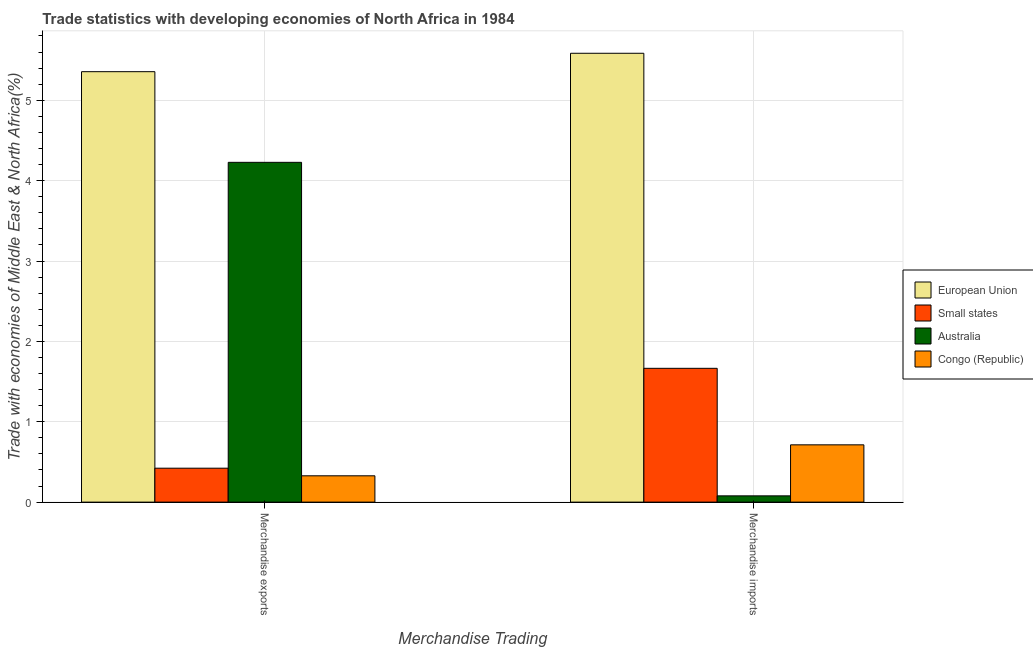Are the number of bars on each tick of the X-axis equal?
Give a very brief answer. Yes. What is the label of the 2nd group of bars from the left?
Provide a succinct answer. Merchandise imports. What is the merchandise imports in Australia?
Give a very brief answer. 0.08. Across all countries, what is the maximum merchandise exports?
Provide a short and direct response. 5.36. Across all countries, what is the minimum merchandise exports?
Provide a succinct answer. 0.33. In which country was the merchandise imports maximum?
Give a very brief answer. European Union. In which country was the merchandise exports minimum?
Make the answer very short. Congo (Republic). What is the total merchandise imports in the graph?
Offer a terse response. 8.04. What is the difference between the merchandise exports in Australia and that in European Union?
Your answer should be very brief. -1.13. What is the difference between the merchandise imports in European Union and the merchandise exports in Congo (Republic)?
Offer a very short reply. 5.26. What is the average merchandise imports per country?
Your answer should be compact. 2.01. What is the difference between the merchandise exports and merchandise imports in Australia?
Offer a very short reply. 4.15. What is the ratio of the merchandise imports in Australia to that in Congo (Republic)?
Your answer should be compact. 0.11. In how many countries, is the merchandise imports greater than the average merchandise imports taken over all countries?
Offer a terse response. 1. What does the 2nd bar from the left in Merchandise exports represents?
Give a very brief answer. Small states. What does the 2nd bar from the right in Merchandise imports represents?
Provide a succinct answer. Australia. How many legend labels are there?
Your response must be concise. 4. How are the legend labels stacked?
Your answer should be compact. Vertical. What is the title of the graph?
Your answer should be very brief. Trade statistics with developing economies of North Africa in 1984. Does "Low income" appear as one of the legend labels in the graph?
Make the answer very short. No. What is the label or title of the X-axis?
Offer a very short reply. Merchandise Trading. What is the label or title of the Y-axis?
Provide a succinct answer. Trade with economies of Middle East & North Africa(%). What is the Trade with economies of Middle East & North Africa(%) in European Union in Merchandise exports?
Your answer should be compact. 5.36. What is the Trade with economies of Middle East & North Africa(%) of Small states in Merchandise exports?
Offer a very short reply. 0.42. What is the Trade with economies of Middle East & North Africa(%) of Australia in Merchandise exports?
Ensure brevity in your answer.  4.23. What is the Trade with economies of Middle East & North Africa(%) in Congo (Republic) in Merchandise exports?
Make the answer very short. 0.33. What is the Trade with economies of Middle East & North Africa(%) in European Union in Merchandise imports?
Offer a terse response. 5.58. What is the Trade with economies of Middle East & North Africa(%) of Small states in Merchandise imports?
Your answer should be very brief. 1.66. What is the Trade with economies of Middle East & North Africa(%) of Australia in Merchandise imports?
Ensure brevity in your answer.  0.08. What is the Trade with economies of Middle East & North Africa(%) in Congo (Republic) in Merchandise imports?
Offer a very short reply. 0.71. Across all Merchandise Trading, what is the maximum Trade with economies of Middle East & North Africa(%) of European Union?
Your answer should be very brief. 5.58. Across all Merchandise Trading, what is the maximum Trade with economies of Middle East & North Africa(%) in Small states?
Your response must be concise. 1.66. Across all Merchandise Trading, what is the maximum Trade with economies of Middle East & North Africa(%) of Australia?
Your answer should be compact. 4.23. Across all Merchandise Trading, what is the maximum Trade with economies of Middle East & North Africa(%) of Congo (Republic)?
Provide a short and direct response. 0.71. Across all Merchandise Trading, what is the minimum Trade with economies of Middle East & North Africa(%) in European Union?
Keep it short and to the point. 5.36. Across all Merchandise Trading, what is the minimum Trade with economies of Middle East & North Africa(%) of Small states?
Provide a short and direct response. 0.42. Across all Merchandise Trading, what is the minimum Trade with economies of Middle East & North Africa(%) in Australia?
Offer a very short reply. 0.08. Across all Merchandise Trading, what is the minimum Trade with economies of Middle East & North Africa(%) in Congo (Republic)?
Your answer should be very brief. 0.33. What is the total Trade with economies of Middle East & North Africa(%) of European Union in the graph?
Offer a very short reply. 10.94. What is the total Trade with economies of Middle East & North Africa(%) of Small states in the graph?
Offer a terse response. 2.09. What is the total Trade with economies of Middle East & North Africa(%) in Australia in the graph?
Provide a short and direct response. 4.31. What is the total Trade with economies of Middle East & North Africa(%) in Congo (Republic) in the graph?
Offer a very short reply. 1.04. What is the difference between the Trade with economies of Middle East & North Africa(%) in European Union in Merchandise exports and that in Merchandise imports?
Offer a very short reply. -0.23. What is the difference between the Trade with economies of Middle East & North Africa(%) in Small states in Merchandise exports and that in Merchandise imports?
Provide a short and direct response. -1.24. What is the difference between the Trade with economies of Middle East & North Africa(%) in Australia in Merchandise exports and that in Merchandise imports?
Keep it short and to the point. 4.15. What is the difference between the Trade with economies of Middle East & North Africa(%) in Congo (Republic) in Merchandise exports and that in Merchandise imports?
Provide a short and direct response. -0.39. What is the difference between the Trade with economies of Middle East & North Africa(%) of European Union in Merchandise exports and the Trade with economies of Middle East & North Africa(%) of Small states in Merchandise imports?
Provide a succinct answer. 3.69. What is the difference between the Trade with economies of Middle East & North Africa(%) in European Union in Merchandise exports and the Trade with economies of Middle East & North Africa(%) in Australia in Merchandise imports?
Your answer should be compact. 5.28. What is the difference between the Trade with economies of Middle East & North Africa(%) of European Union in Merchandise exports and the Trade with economies of Middle East & North Africa(%) of Congo (Republic) in Merchandise imports?
Make the answer very short. 4.64. What is the difference between the Trade with economies of Middle East & North Africa(%) of Small states in Merchandise exports and the Trade with economies of Middle East & North Africa(%) of Australia in Merchandise imports?
Provide a short and direct response. 0.34. What is the difference between the Trade with economies of Middle East & North Africa(%) of Small states in Merchandise exports and the Trade with economies of Middle East & North Africa(%) of Congo (Republic) in Merchandise imports?
Offer a very short reply. -0.29. What is the difference between the Trade with economies of Middle East & North Africa(%) of Australia in Merchandise exports and the Trade with economies of Middle East & North Africa(%) of Congo (Republic) in Merchandise imports?
Give a very brief answer. 3.52. What is the average Trade with economies of Middle East & North Africa(%) in European Union per Merchandise Trading?
Your answer should be compact. 5.47. What is the average Trade with economies of Middle East & North Africa(%) in Small states per Merchandise Trading?
Give a very brief answer. 1.04. What is the average Trade with economies of Middle East & North Africa(%) of Australia per Merchandise Trading?
Ensure brevity in your answer.  2.15. What is the average Trade with economies of Middle East & North Africa(%) in Congo (Republic) per Merchandise Trading?
Offer a terse response. 0.52. What is the difference between the Trade with economies of Middle East & North Africa(%) of European Union and Trade with economies of Middle East & North Africa(%) of Small states in Merchandise exports?
Your answer should be compact. 4.93. What is the difference between the Trade with economies of Middle East & North Africa(%) in European Union and Trade with economies of Middle East & North Africa(%) in Australia in Merchandise exports?
Offer a terse response. 1.13. What is the difference between the Trade with economies of Middle East & North Africa(%) of European Union and Trade with economies of Middle East & North Africa(%) of Congo (Republic) in Merchandise exports?
Make the answer very short. 5.03. What is the difference between the Trade with economies of Middle East & North Africa(%) in Small states and Trade with economies of Middle East & North Africa(%) in Australia in Merchandise exports?
Make the answer very short. -3.81. What is the difference between the Trade with economies of Middle East & North Africa(%) in Small states and Trade with economies of Middle East & North Africa(%) in Congo (Republic) in Merchandise exports?
Provide a succinct answer. 0.09. What is the difference between the Trade with economies of Middle East & North Africa(%) of Australia and Trade with economies of Middle East & North Africa(%) of Congo (Republic) in Merchandise exports?
Provide a short and direct response. 3.9. What is the difference between the Trade with economies of Middle East & North Africa(%) of European Union and Trade with economies of Middle East & North Africa(%) of Small states in Merchandise imports?
Keep it short and to the point. 3.92. What is the difference between the Trade with economies of Middle East & North Africa(%) of European Union and Trade with economies of Middle East & North Africa(%) of Australia in Merchandise imports?
Your response must be concise. 5.51. What is the difference between the Trade with economies of Middle East & North Africa(%) of European Union and Trade with economies of Middle East & North Africa(%) of Congo (Republic) in Merchandise imports?
Give a very brief answer. 4.87. What is the difference between the Trade with economies of Middle East & North Africa(%) in Small states and Trade with economies of Middle East & North Africa(%) in Australia in Merchandise imports?
Provide a succinct answer. 1.59. What is the difference between the Trade with economies of Middle East & North Africa(%) of Small states and Trade with economies of Middle East & North Africa(%) of Congo (Republic) in Merchandise imports?
Offer a terse response. 0.95. What is the difference between the Trade with economies of Middle East & North Africa(%) in Australia and Trade with economies of Middle East & North Africa(%) in Congo (Republic) in Merchandise imports?
Ensure brevity in your answer.  -0.63. What is the ratio of the Trade with economies of Middle East & North Africa(%) in Small states in Merchandise exports to that in Merchandise imports?
Give a very brief answer. 0.25. What is the ratio of the Trade with economies of Middle East & North Africa(%) in Australia in Merchandise exports to that in Merchandise imports?
Offer a very short reply. 54.1. What is the ratio of the Trade with economies of Middle East & North Africa(%) in Congo (Republic) in Merchandise exports to that in Merchandise imports?
Provide a short and direct response. 0.46. What is the difference between the highest and the second highest Trade with economies of Middle East & North Africa(%) in European Union?
Your response must be concise. 0.23. What is the difference between the highest and the second highest Trade with economies of Middle East & North Africa(%) of Small states?
Keep it short and to the point. 1.24. What is the difference between the highest and the second highest Trade with economies of Middle East & North Africa(%) of Australia?
Offer a terse response. 4.15. What is the difference between the highest and the second highest Trade with economies of Middle East & North Africa(%) in Congo (Republic)?
Ensure brevity in your answer.  0.39. What is the difference between the highest and the lowest Trade with economies of Middle East & North Africa(%) of European Union?
Make the answer very short. 0.23. What is the difference between the highest and the lowest Trade with economies of Middle East & North Africa(%) of Small states?
Your answer should be very brief. 1.24. What is the difference between the highest and the lowest Trade with economies of Middle East & North Africa(%) in Australia?
Your answer should be compact. 4.15. What is the difference between the highest and the lowest Trade with economies of Middle East & North Africa(%) in Congo (Republic)?
Offer a very short reply. 0.39. 